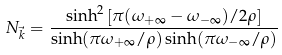Convert formula to latex. <formula><loc_0><loc_0><loc_500><loc_500>N _ { \vec { k } } = \frac { \sinh ^ { 2 } \left [ \pi ( \omega _ { + \infty } - \omega _ { - \infty } ) / 2 \rho \right ] } { \sinh ( \pi \omega _ { + \infty } / \rho ) \sinh ( \pi \omega _ { - \infty } / \rho ) }</formula> 